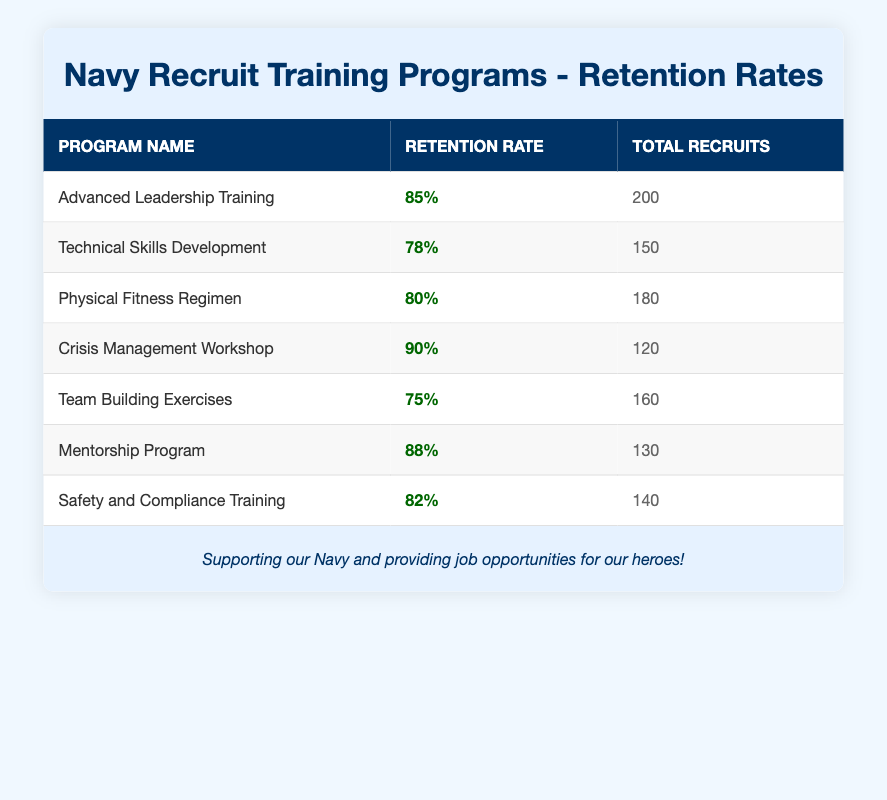What is the retention rate for the Crisis Management Workshop? The retention rate for the Crisis Management Workshop is listed directly in the table. It states "90%" in the corresponding retention rate column.
Answer: 90% Which training program has the highest retention rate? By examining each retention rate listed, the Crisis Management Workshop has the highest rate at 90%.
Answer: Crisis Management Workshop What is the total number of recruits that participated in the Advanced Leadership Training program? The table directly provides the total number of recruits for the Advanced Leadership Training program, which is stated as "200".
Answer: 200 Calculate the average retention rate across all training programs. First, we sum the retention rates: 85 + 78 + 80 + 90 + 75 + 88 + 82 = 528. Then, divide by the number of programs (7): 528 / 7 = 75.43 (rounded to two decimal places).
Answer: 75.43 Is the retention rate for Safety and Compliance Training higher than for Team Building Exercises? The retention rate for Safety and Compliance Training is 82%, while for Team Building Exercises it is 75%. Since 82% is greater than 75%, the statement is true.
Answer: Yes Which program has a retention rate lower than 80%? By reviewing the retention rates, only the Technical Skills Development program has a retention rate of 78%, which is lower than 80%.
Answer: Technical Skills Development If 150 recruits went through the Mentorship Program, how many more recruits retained their positions compared to the Team Building Exercises (with 160 recruits)? For the Mentorship Program, 88% of 150 recruits were retained, calculated as 0.88 * 150 = 132. For Team Building Exercises, 75% of 160 recruits were retained, calculated as 0.75 * 160 = 120. The difference is 132 - 120 = 12, meaning 12 more recruits retained their positions in the Mentorship Program.
Answer: 12 What is the total number of recruits across all training programs? To find the total number of recruits, add each program's total: 200 + 150 + 180 + 120 + 160 + 130 + 140 = 1080.
Answer: 1080 Is the retention rate for the Physical Fitness Regimen greater than or equal to 80%? The retention rate for the Physical Fitness Regimen is stated as 80%. Since it is equal to 80%, the answer is yes.
Answer: Yes 